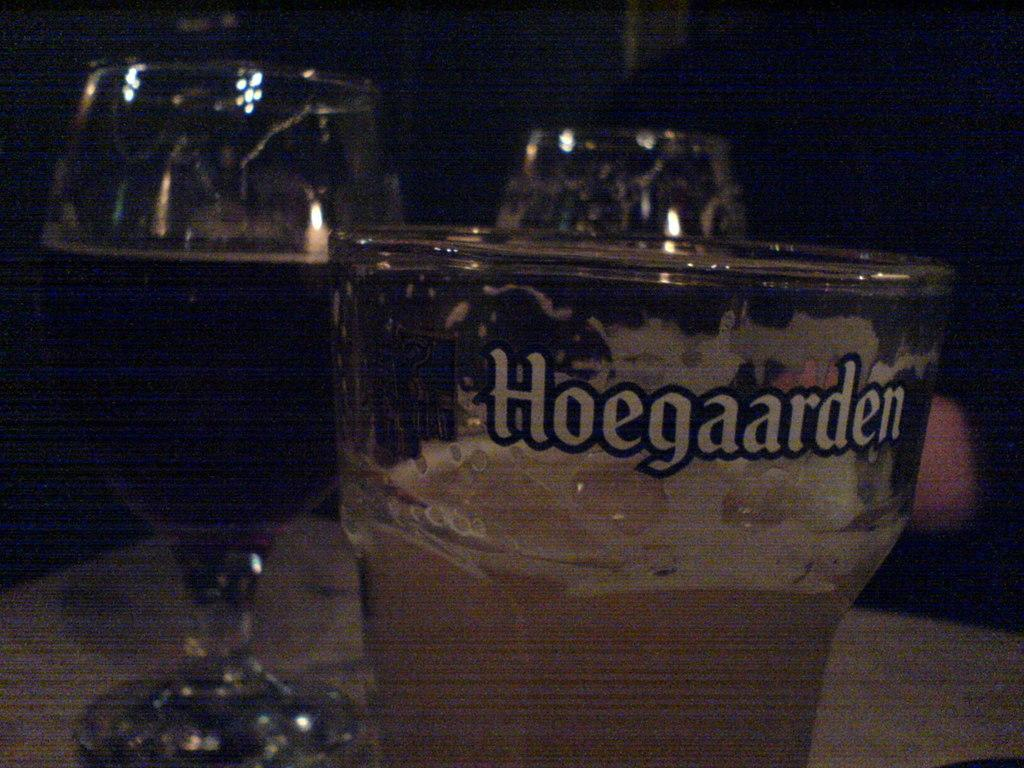<image>
Describe the image concisely. A glass of beer with the word Hoegaarden written on it 